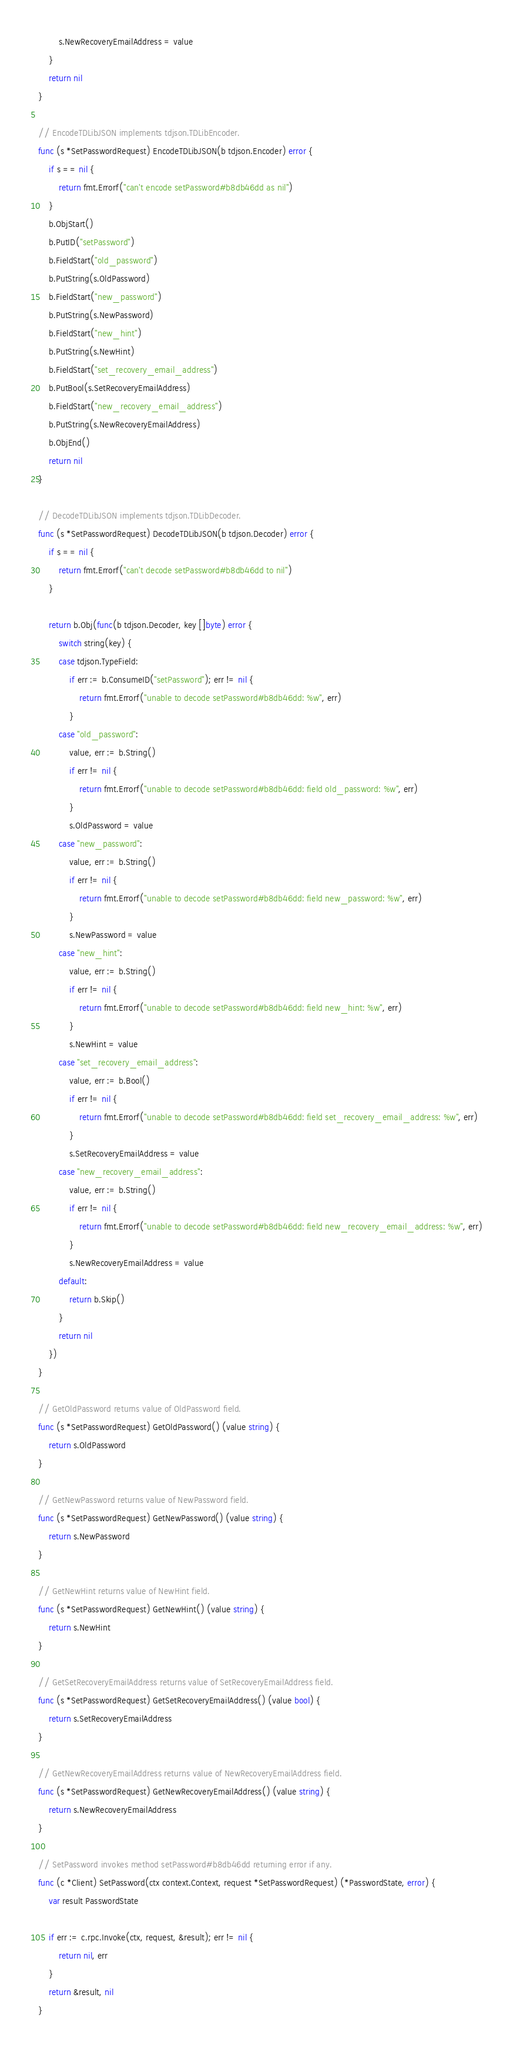Convert code to text. <code><loc_0><loc_0><loc_500><loc_500><_Go_>		s.NewRecoveryEmailAddress = value
	}
	return nil
}

// EncodeTDLibJSON implements tdjson.TDLibEncoder.
func (s *SetPasswordRequest) EncodeTDLibJSON(b tdjson.Encoder) error {
	if s == nil {
		return fmt.Errorf("can't encode setPassword#b8db46dd as nil")
	}
	b.ObjStart()
	b.PutID("setPassword")
	b.FieldStart("old_password")
	b.PutString(s.OldPassword)
	b.FieldStart("new_password")
	b.PutString(s.NewPassword)
	b.FieldStart("new_hint")
	b.PutString(s.NewHint)
	b.FieldStart("set_recovery_email_address")
	b.PutBool(s.SetRecoveryEmailAddress)
	b.FieldStart("new_recovery_email_address")
	b.PutString(s.NewRecoveryEmailAddress)
	b.ObjEnd()
	return nil
}

// DecodeTDLibJSON implements tdjson.TDLibDecoder.
func (s *SetPasswordRequest) DecodeTDLibJSON(b tdjson.Decoder) error {
	if s == nil {
		return fmt.Errorf("can't decode setPassword#b8db46dd to nil")
	}

	return b.Obj(func(b tdjson.Decoder, key []byte) error {
		switch string(key) {
		case tdjson.TypeField:
			if err := b.ConsumeID("setPassword"); err != nil {
				return fmt.Errorf("unable to decode setPassword#b8db46dd: %w", err)
			}
		case "old_password":
			value, err := b.String()
			if err != nil {
				return fmt.Errorf("unable to decode setPassword#b8db46dd: field old_password: %w", err)
			}
			s.OldPassword = value
		case "new_password":
			value, err := b.String()
			if err != nil {
				return fmt.Errorf("unable to decode setPassword#b8db46dd: field new_password: %w", err)
			}
			s.NewPassword = value
		case "new_hint":
			value, err := b.String()
			if err != nil {
				return fmt.Errorf("unable to decode setPassword#b8db46dd: field new_hint: %w", err)
			}
			s.NewHint = value
		case "set_recovery_email_address":
			value, err := b.Bool()
			if err != nil {
				return fmt.Errorf("unable to decode setPassword#b8db46dd: field set_recovery_email_address: %w", err)
			}
			s.SetRecoveryEmailAddress = value
		case "new_recovery_email_address":
			value, err := b.String()
			if err != nil {
				return fmt.Errorf("unable to decode setPassword#b8db46dd: field new_recovery_email_address: %w", err)
			}
			s.NewRecoveryEmailAddress = value
		default:
			return b.Skip()
		}
		return nil
	})
}

// GetOldPassword returns value of OldPassword field.
func (s *SetPasswordRequest) GetOldPassword() (value string) {
	return s.OldPassword
}

// GetNewPassword returns value of NewPassword field.
func (s *SetPasswordRequest) GetNewPassword() (value string) {
	return s.NewPassword
}

// GetNewHint returns value of NewHint field.
func (s *SetPasswordRequest) GetNewHint() (value string) {
	return s.NewHint
}

// GetSetRecoveryEmailAddress returns value of SetRecoveryEmailAddress field.
func (s *SetPasswordRequest) GetSetRecoveryEmailAddress() (value bool) {
	return s.SetRecoveryEmailAddress
}

// GetNewRecoveryEmailAddress returns value of NewRecoveryEmailAddress field.
func (s *SetPasswordRequest) GetNewRecoveryEmailAddress() (value string) {
	return s.NewRecoveryEmailAddress
}

// SetPassword invokes method setPassword#b8db46dd returning error if any.
func (c *Client) SetPassword(ctx context.Context, request *SetPasswordRequest) (*PasswordState, error) {
	var result PasswordState

	if err := c.rpc.Invoke(ctx, request, &result); err != nil {
		return nil, err
	}
	return &result, nil
}
</code> 